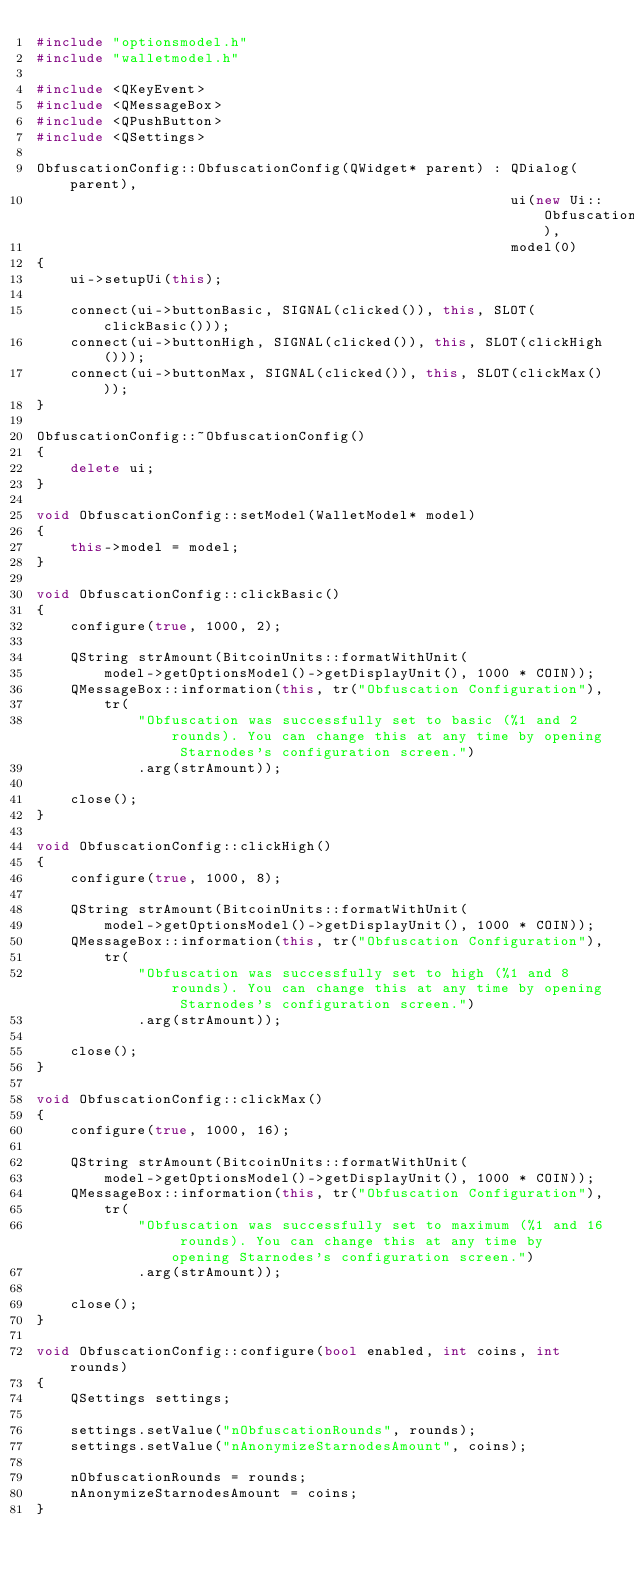<code> <loc_0><loc_0><loc_500><loc_500><_C++_>#include "optionsmodel.h"
#include "walletmodel.h"

#include <QKeyEvent>
#include <QMessageBox>
#include <QPushButton>
#include <QSettings>

ObfuscationConfig::ObfuscationConfig(QWidget* parent) : QDialog(parent),
                                                        ui(new Ui::ObfuscationConfig),
                                                        model(0)
{
    ui->setupUi(this);

    connect(ui->buttonBasic, SIGNAL(clicked()), this, SLOT(clickBasic()));
    connect(ui->buttonHigh, SIGNAL(clicked()), this, SLOT(clickHigh()));
    connect(ui->buttonMax, SIGNAL(clicked()), this, SLOT(clickMax()));
}

ObfuscationConfig::~ObfuscationConfig()
{
    delete ui;
}

void ObfuscationConfig::setModel(WalletModel* model)
{
    this->model = model;
}

void ObfuscationConfig::clickBasic()
{
    configure(true, 1000, 2);

    QString strAmount(BitcoinUnits::formatWithUnit(
        model->getOptionsModel()->getDisplayUnit(), 1000 * COIN));
    QMessageBox::information(this, tr("Obfuscation Configuration"),
        tr(
            "Obfuscation was successfully set to basic (%1 and 2 rounds). You can change this at any time by opening Starnodes's configuration screen.")
            .arg(strAmount));

    close();
}

void ObfuscationConfig::clickHigh()
{
    configure(true, 1000, 8);

    QString strAmount(BitcoinUnits::formatWithUnit(
        model->getOptionsModel()->getDisplayUnit(), 1000 * COIN));
    QMessageBox::information(this, tr("Obfuscation Configuration"),
        tr(
            "Obfuscation was successfully set to high (%1 and 8 rounds). You can change this at any time by opening Starnodes's configuration screen.")
            .arg(strAmount));

    close();
}

void ObfuscationConfig::clickMax()
{
    configure(true, 1000, 16);

    QString strAmount(BitcoinUnits::formatWithUnit(
        model->getOptionsModel()->getDisplayUnit(), 1000 * COIN));
    QMessageBox::information(this, tr("Obfuscation Configuration"),
        tr(
            "Obfuscation was successfully set to maximum (%1 and 16 rounds). You can change this at any time by opening Starnodes's configuration screen.")
            .arg(strAmount));

    close();
}

void ObfuscationConfig::configure(bool enabled, int coins, int rounds)
{
    QSettings settings;

    settings.setValue("nObfuscationRounds", rounds);
    settings.setValue("nAnonymizeStarnodesAmount", coins);

    nObfuscationRounds = rounds;
    nAnonymizeStarnodesAmount = coins;
}
</code> 